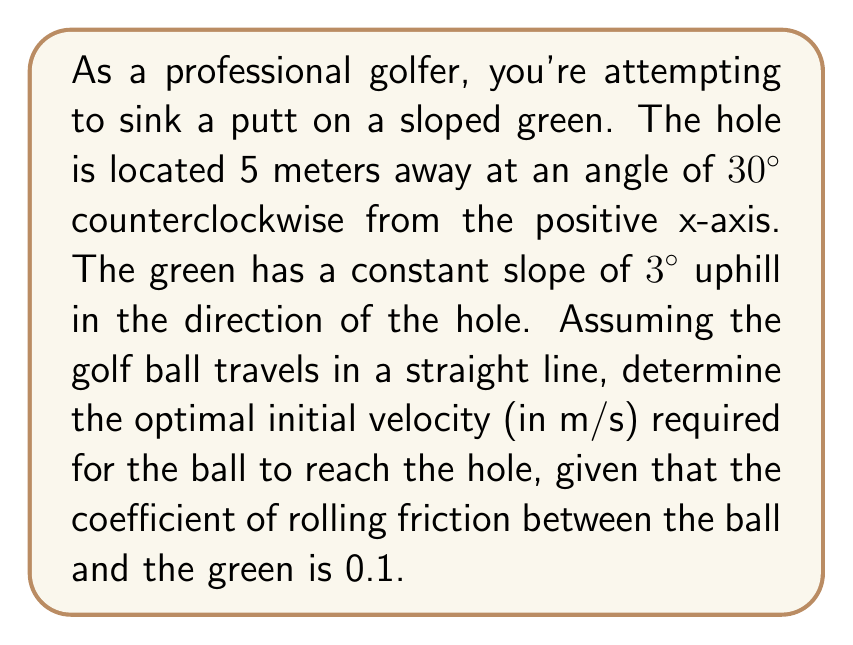What is the answer to this math problem? Let's approach this problem step by step using polar coordinates:

1) First, we need to convert the hole's position from polar to Cartesian coordinates:
   $x = r \cos(\theta) = 5 \cos(30°) = 4.33$ m
   $y = r \sin(\theta) = 5 \sin(30°) = 2.5$ m

2) The distance the ball needs to travel is 5 meters (given in the question).

3) We need to consider the effect of gravity on the sloped surface. The component of gravity parallel to the slope is:
   $g_{\parallel} = g \sin(3°) = 9.81 \sin(3°) = 0.514$ m/s²

4) The force of friction is given by:
   $F_f = \mu m g \cos(3°)$
   where $\mu$ is the coefficient of friction, $m$ is the mass of the ball, and $g$ is the acceleration due to gravity.

5) The acceleration due to friction is:
   $a_f = \mu g \cos(3°) = 0.1 \times 9.81 \cos(3°) = 0.979$ m/s²

6) The total deceleration of the ball is:
   $a = g_{\parallel} + a_f = 0.514 + 0.979 = 1.493$ m/s²

7) We can use the equation of motion:
   $v^2 = u^2 + 2as$
   where $v$ is the final velocity (0 m/s), $u$ is the initial velocity, $a$ is the deceleration, and $s$ is the distance.

8) Substituting our values:
   $0 = u^2 - 2(1.493)(5)$
   $u^2 = 14.93$
   $u = \sqrt{14.93} = 3.86$ m/s

Therefore, the optimal initial velocity is approximately 3.86 m/s.
Answer: $$u = 3.86 \text{ m/s}$$ 